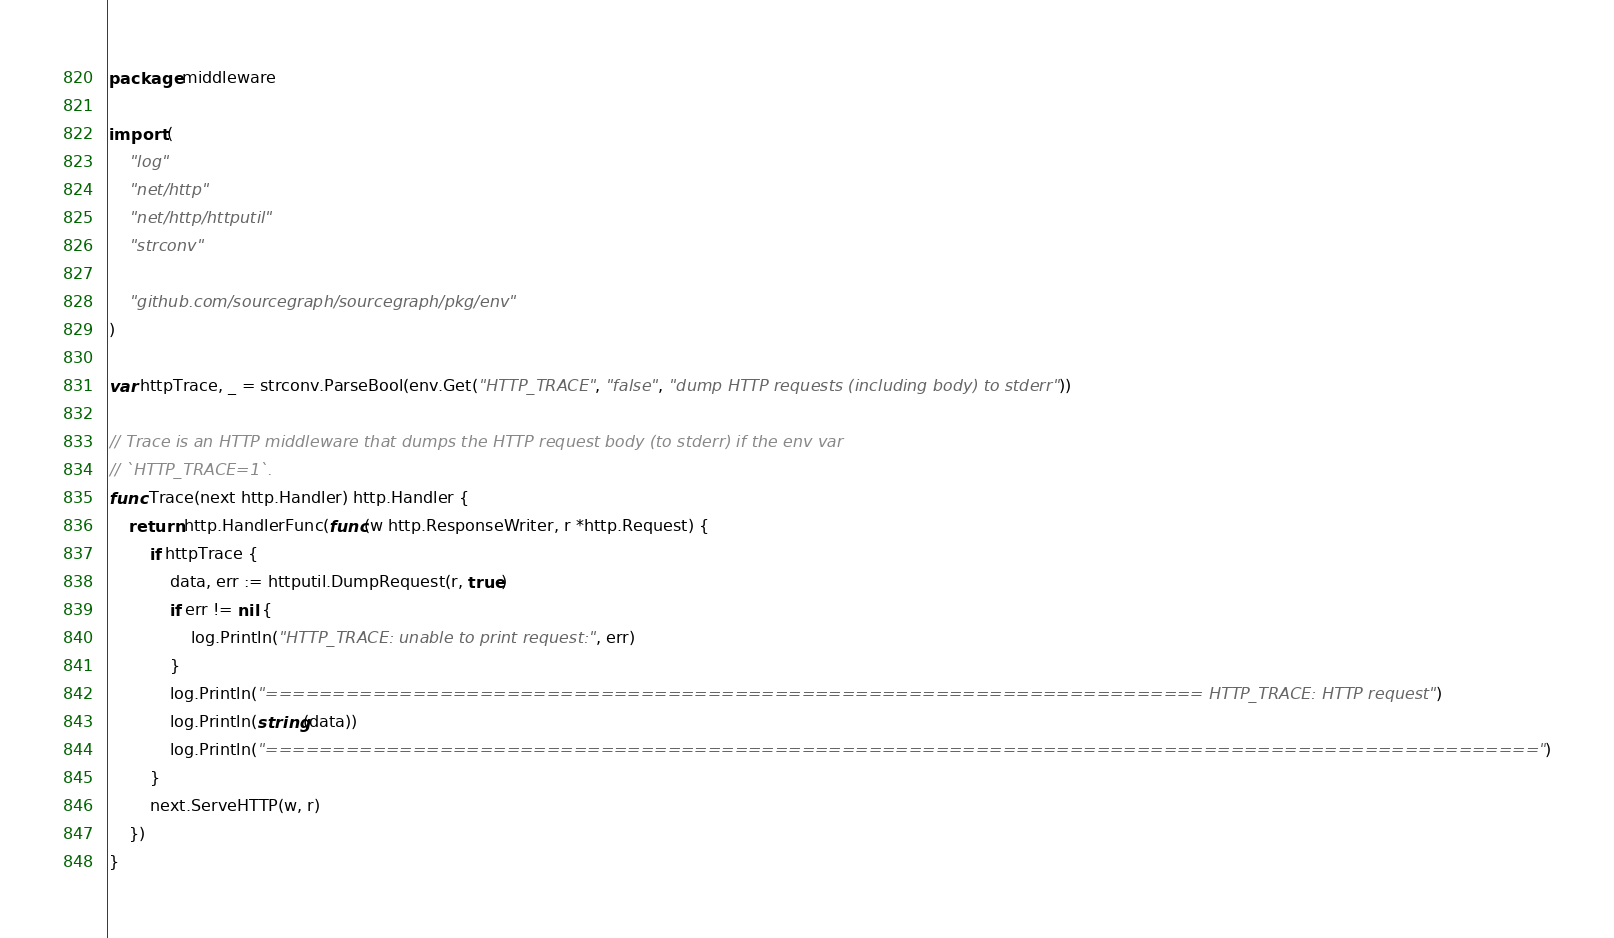<code> <loc_0><loc_0><loc_500><loc_500><_Go_>package middleware

import (
	"log"
	"net/http"
	"net/http/httputil"
	"strconv"

	"github.com/sourcegraph/sourcegraph/pkg/env"
)

var httpTrace, _ = strconv.ParseBool(env.Get("HTTP_TRACE", "false", "dump HTTP requests (including body) to stderr"))

// Trace is an HTTP middleware that dumps the HTTP request body (to stderr) if the env var
// `HTTP_TRACE=1`.
func Trace(next http.Handler) http.Handler {
	return http.HandlerFunc(func(w http.ResponseWriter, r *http.Request) {
		if httpTrace {
			data, err := httputil.DumpRequest(r, true)
			if err != nil {
				log.Println("HTTP_TRACE: unable to print request:", err)
			}
			log.Println("====================================================================== HTTP_TRACE: HTTP request")
			log.Println(string(data))
			log.Println("===============================================================================================")
		}
		next.ServeHTTP(w, r)
	})
}
</code> 